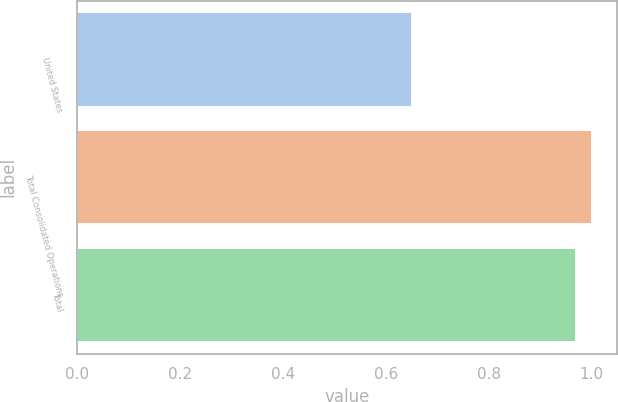Convert chart. <chart><loc_0><loc_0><loc_500><loc_500><bar_chart><fcel>United States<fcel>Total Consolidated Operations<fcel>Total<nl><fcel>0.65<fcel>1<fcel>0.97<nl></chart> 